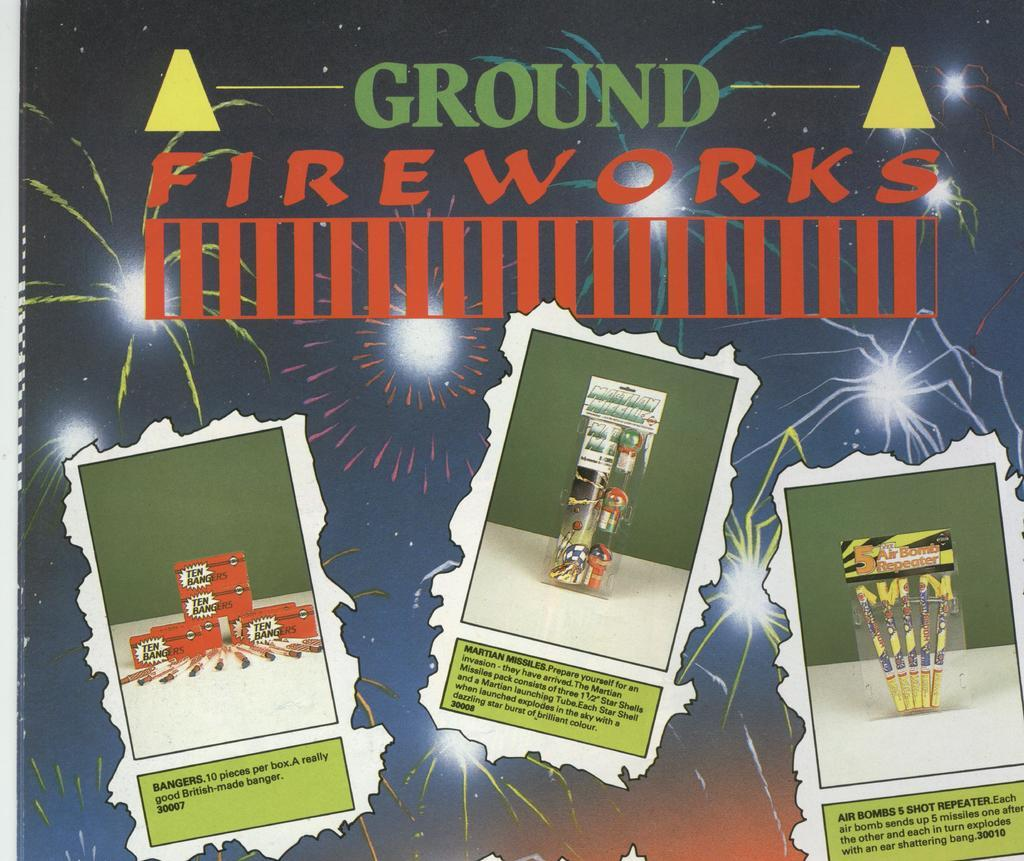<image>
Provide a brief description of the given image. three separate images of ground fireworks with the one further to the left called bangers 